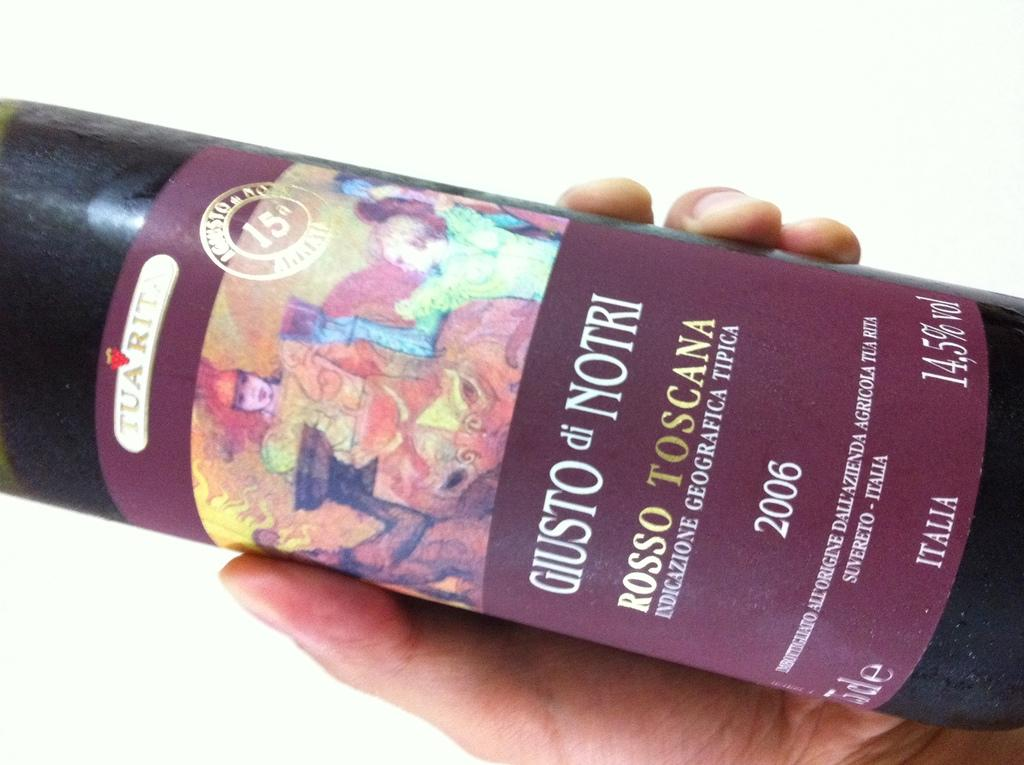<image>
Summarize the visual content of the image. A bottle of GIUSTO di NORTI red wine. 